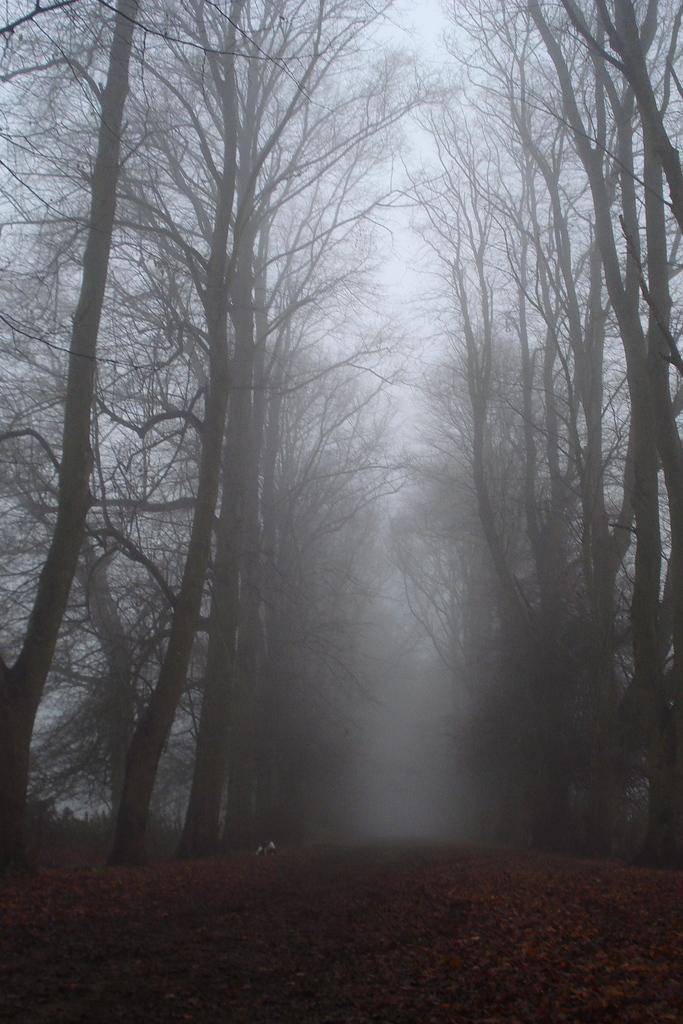How would you summarize this image in a sentence or two? There is a walkway in the center. There are dry trees on the either sides. There is fog at the back. 